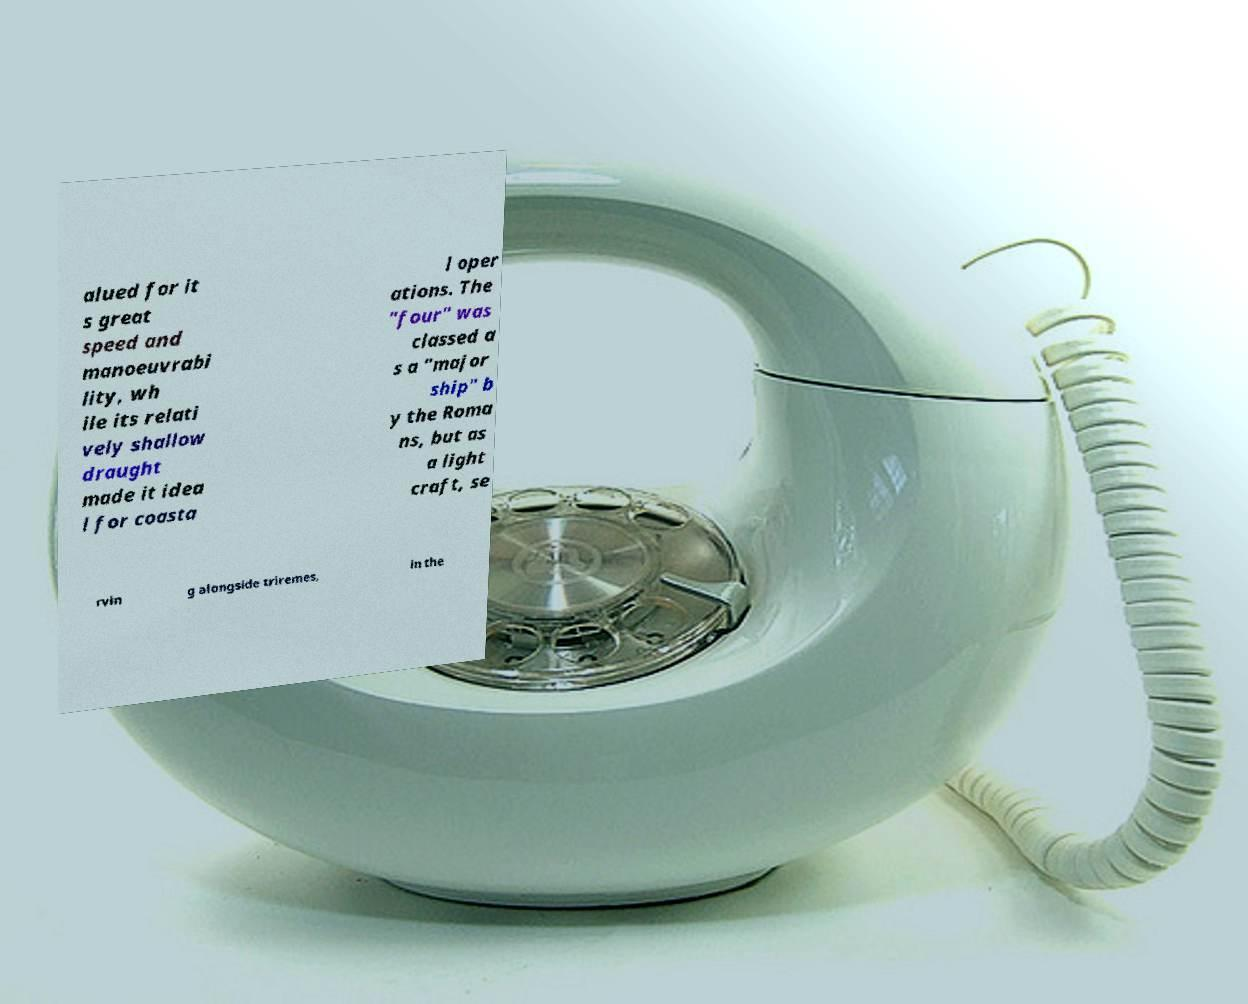There's text embedded in this image that I need extracted. Can you transcribe it verbatim? alued for it s great speed and manoeuvrabi lity, wh ile its relati vely shallow draught made it idea l for coasta l oper ations. The "four" was classed a s a "major ship" b y the Roma ns, but as a light craft, se rvin g alongside triremes, in the 